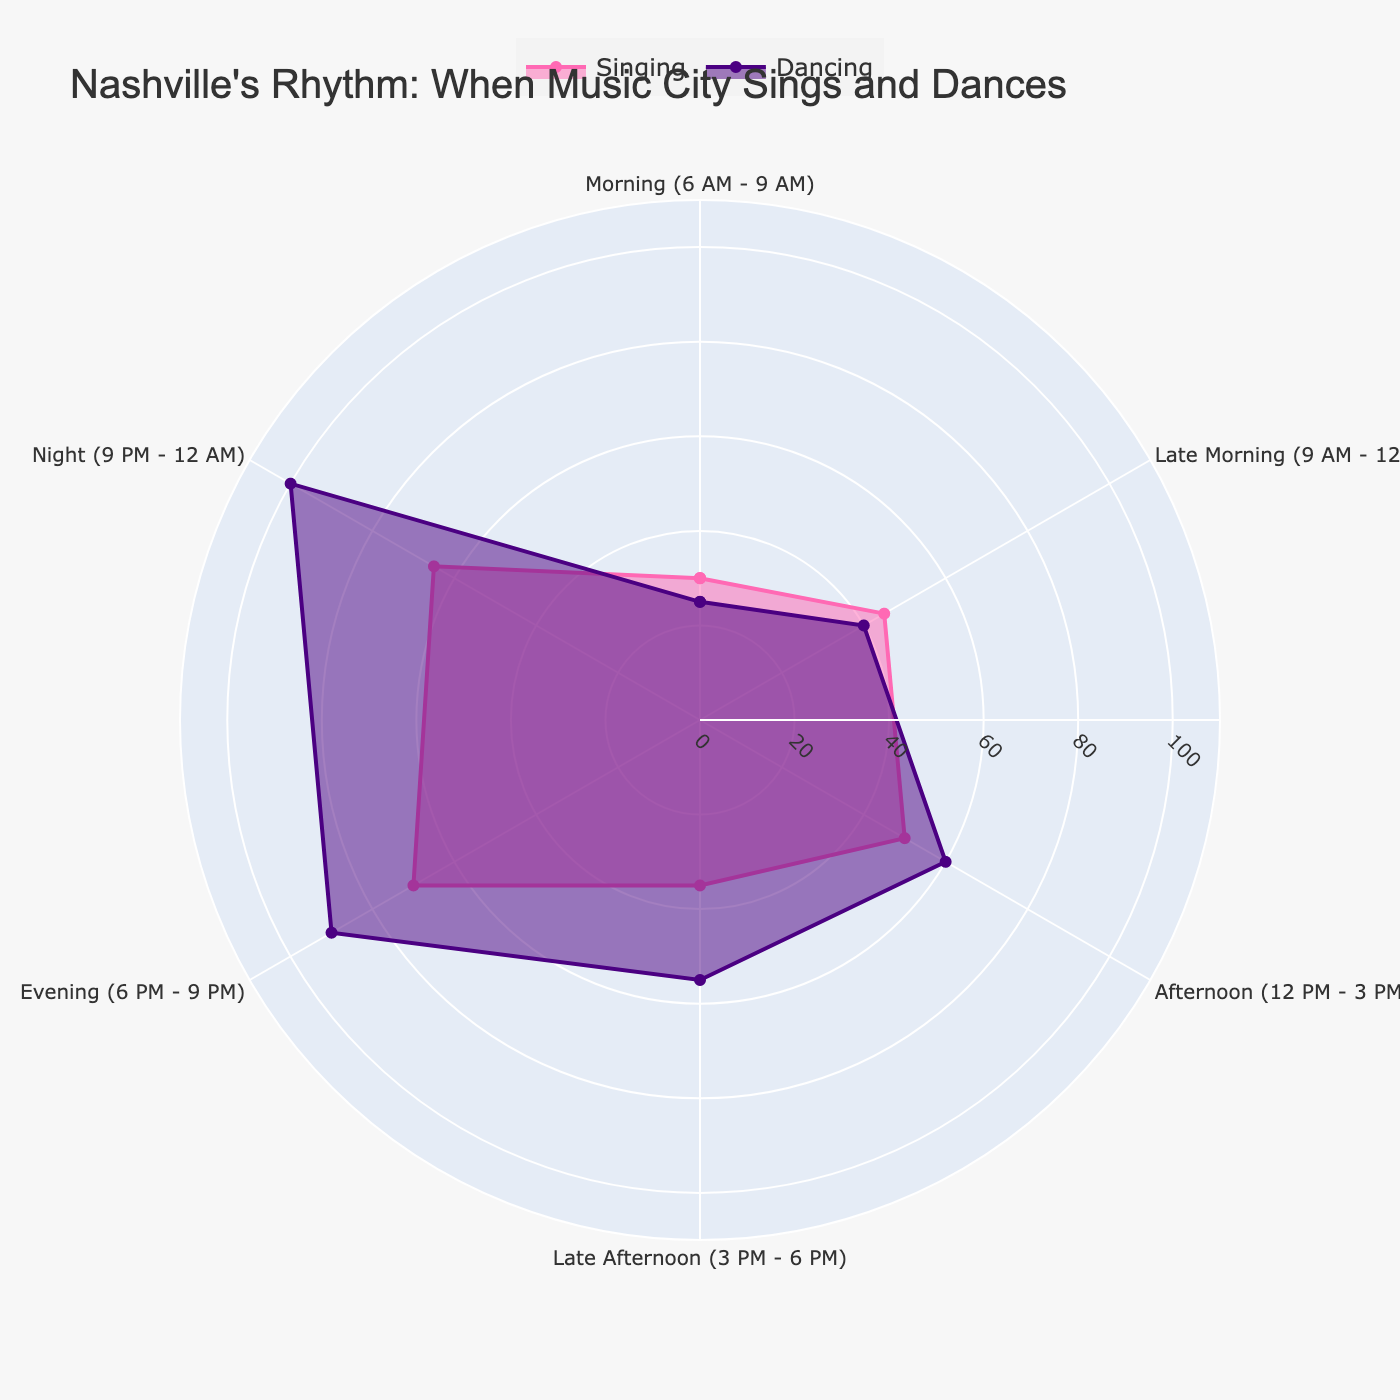What is the title of the figure? The title of the figure is written at the top and it provides a descriptive overview of the chart's subject.
Answer: Nashville's Rhythm: When Music City Sings and Dances Which activity has the highest frequency during the night (9 PM - 12 AM)? Locate the section for Night (9 PM - 12 AM) on the chart. Compare the radial lengths of the sections for singing and dancing.
Answer: Dancing During which time of day is singing most frequent? Look at the radial lengths for all singing activities at different times of the day and identify the longest.
Answer: Evening (6 PM - 9 PM) What is the frequency difference between dancing at clubs and singing at parties? Find the radial lengths representing dancing at clubs and singing at parties, then subtract the latter from the former.
Answer: 35 How many time segments are displayed on the polar plot? Count the distinct sections around the polar plot that represent different time segments.
Answer: 5 Combine the frequencies of singing and dancing in the late morning (9 AM - 12 PM). What is the total? Sum the radial lengths for both singing and dancing activities during late morning.
Answer: 85 Which activity shows a higher frequency in the afternoon (12 PM - 3 PM), singing or dancing? Compare the radial lengths for singing and dancing during the afternoon segment.
Answer: Dancing What is the average frequency of all singing activities throughout the day? Add up the frequencies of all singing activities and divide by the number of singing activities.
Answer: 49.17 In which time segment is the frequency difference between singing and dancing the smallest? Calculate the difference in frequency between singing and dancing for each time segment and find the smallest difference.
Answer: Late morning (9 AM - 12 PM) What color represents dancing activities on the chart? Observe the color used to fill the area for dancing activities.
Answer: Indigo 